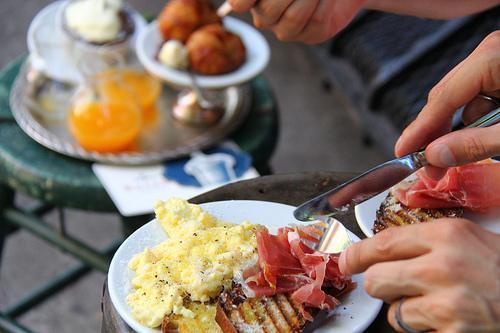How many people are eating?
Give a very brief answer. 2. How many rings do you see?
Give a very brief answer. 1. 